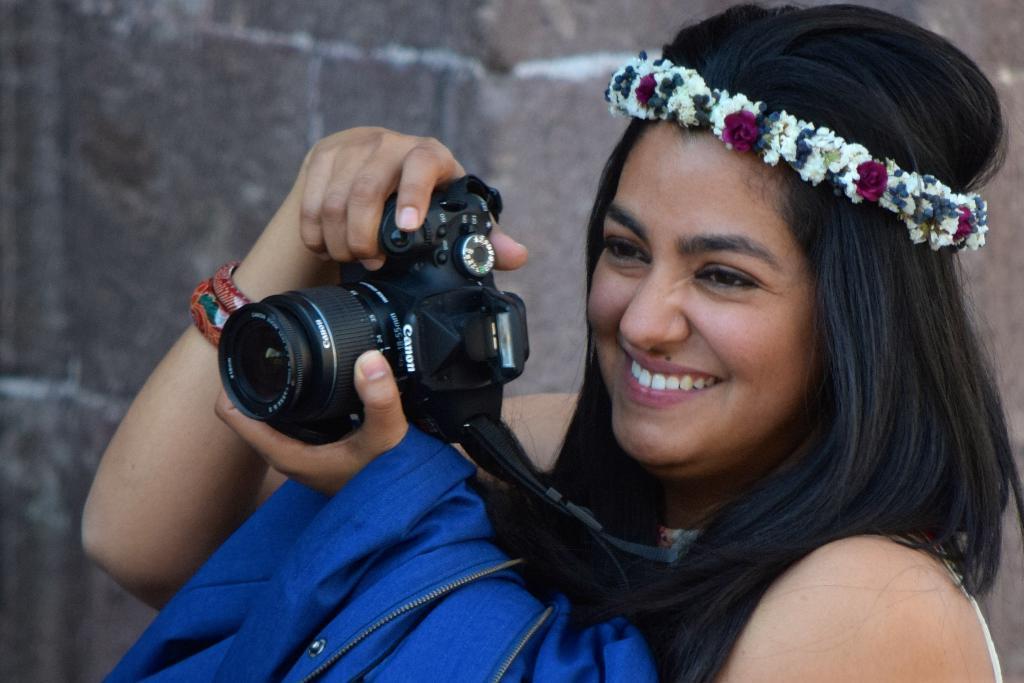Describe this image in one or two sentences. This woman is holding a camera, smile, wore crown and holding a jacket. 